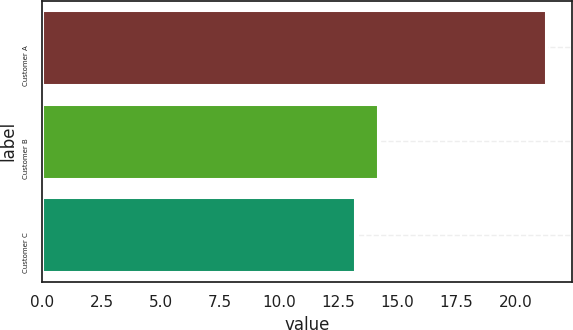Convert chart to OTSL. <chart><loc_0><loc_0><loc_500><loc_500><bar_chart><fcel>Customer A<fcel>Customer B<fcel>Customer C<nl><fcel>21.3<fcel>14.2<fcel>13.2<nl></chart> 